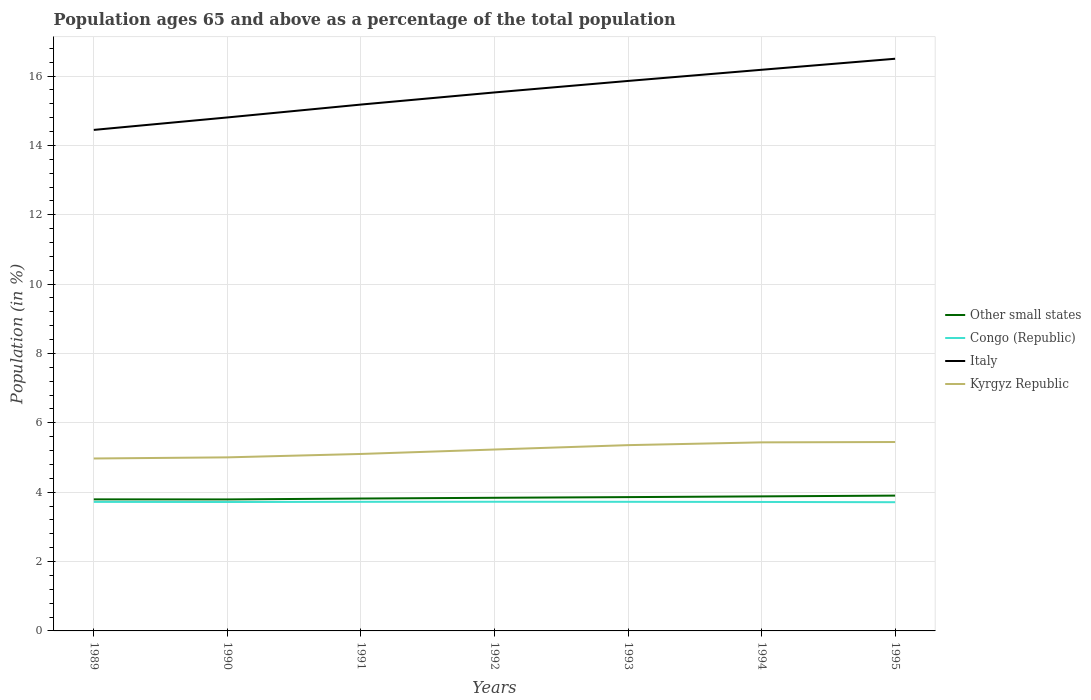How many different coloured lines are there?
Your answer should be very brief. 4. Across all years, what is the maximum percentage of the population ages 65 and above in Italy?
Keep it short and to the point. 14.45. What is the total percentage of the population ages 65 and above in Italy in the graph?
Provide a short and direct response. -1.69. What is the difference between the highest and the second highest percentage of the population ages 65 and above in Other small states?
Your response must be concise. 0.11. Is the percentage of the population ages 65 and above in Other small states strictly greater than the percentage of the population ages 65 and above in Italy over the years?
Offer a very short reply. Yes. What is the difference between two consecutive major ticks on the Y-axis?
Ensure brevity in your answer.  2. Where does the legend appear in the graph?
Your answer should be compact. Center right. How many legend labels are there?
Make the answer very short. 4. How are the legend labels stacked?
Provide a succinct answer. Vertical. What is the title of the graph?
Your answer should be compact. Population ages 65 and above as a percentage of the total population. What is the label or title of the X-axis?
Your answer should be very brief. Years. What is the Population (in %) in Other small states in 1989?
Provide a succinct answer. 3.79. What is the Population (in %) of Congo (Republic) in 1989?
Provide a succinct answer. 3.72. What is the Population (in %) in Italy in 1989?
Offer a terse response. 14.45. What is the Population (in %) in Kyrgyz Republic in 1989?
Keep it short and to the point. 4.97. What is the Population (in %) in Other small states in 1990?
Offer a very short reply. 3.79. What is the Population (in %) of Congo (Republic) in 1990?
Keep it short and to the point. 3.72. What is the Population (in %) of Italy in 1990?
Ensure brevity in your answer.  14.81. What is the Population (in %) in Kyrgyz Republic in 1990?
Give a very brief answer. 5. What is the Population (in %) in Other small states in 1991?
Provide a short and direct response. 3.82. What is the Population (in %) in Congo (Republic) in 1991?
Offer a very short reply. 3.72. What is the Population (in %) of Italy in 1991?
Provide a succinct answer. 15.18. What is the Population (in %) of Kyrgyz Republic in 1991?
Offer a very short reply. 5.1. What is the Population (in %) in Other small states in 1992?
Give a very brief answer. 3.84. What is the Population (in %) in Congo (Republic) in 1992?
Provide a succinct answer. 3.72. What is the Population (in %) in Italy in 1992?
Give a very brief answer. 15.53. What is the Population (in %) in Kyrgyz Republic in 1992?
Your response must be concise. 5.23. What is the Population (in %) in Other small states in 1993?
Ensure brevity in your answer.  3.86. What is the Population (in %) of Congo (Republic) in 1993?
Offer a very short reply. 3.72. What is the Population (in %) in Italy in 1993?
Offer a terse response. 15.86. What is the Population (in %) of Kyrgyz Republic in 1993?
Make the answer very short. 5.36. What is the Population (in %) of Other small states in 1994?
Give a very brief answer. 3.88. What is the Population (in %) of Congo (Republic) in 1994?
Your response must be concise. 3.72. What is the Population (in %) of Italy in 1994?
Your answer should be compact. 16.18. What is the Population (in %) in Kyrgyz Republic in 1994?
Your response must be concise. 5.44. What is the Population (in %) in Other small states in 1995?
Ensure brevity in your answer.  3.9. What is the Population (in %) of Congo (Republic) in 1995?
Your response must be concise. 3.71. What is the Population (in %) in Italy in 1995?
Ensure brevity in your answer.  16.5. What is the Population (in %) of Kyrgyz Republic in 1995?
Make the answer very short. 5.45. Across all years, what is the maximum Population (in %) in Other small states?
Give a very brief answer. 3.9. Across all years, what is the maximum Population (in %) in Congo (Republic)?
Make the answer very short. 3.72. Across all years, what is the maximum Population (in %) of Italy?
Ensure brevity in your answer.  16.5. Across all years, what is the maximum Population (in %) in Kyrgyz Republic?
Your answer should be very brief. 5.45. Across all years, what is the minimum Population (in %) in Other small states?
Your answer should be compact. 3.79. Across all years, what is the minimum Population (in %) in Congo (Republic)?
Provide a succinct answer. 3.71. Across all years, what is the minimum Population (in %) of Italy?
Give a very brief answer. 14.45. Across all years, what is the minimum Population (in %) in Kyrgyz Republic?
Provide a short and direct response. 4.97. What is the total Population (in %) of Other small states in the graph?
Ensure brevity in your answer.  26.88. What is the total Population (in %) in Congo (Republic) in the graph?
Provide a short and direct response. 26.04. What is the total Population (in %) of Italy in the graph?
Keep it short and to the point. 108.5. What is the total Population (in %) of Kyrgyz Republic in the graph?
Ensure brevity in your answer.  36.55. What is the difference between the Population (in %) of Other small states in 1989 and that in 1990?
Give a very brief answer. 0. What is the difference between the Population (in %) in Congo (Republic) in 1989 and that in 1990?
Provide a short and direct response. 0. What is the difference between the Population (in %) of Italy in 1989 and that in 1990?
Ensure brevity in your answer.  -0.36. What is the difference between the Population (in %) in Kyrgyz Republic in 1989 and that in 1990?
Make the answer very short. -0.03. What is the difference between the Population (in %) in Other small states in 1989 and that in 1991?
Offer a very short reply. -0.02. What is the difference between the Population (in %) of Congo (Republic) in 1989 and that in 1991?
Provide a short and direct response. -0. What is the difference between the Population (in %) of Italy in 1989 and that in 1991?
Offer a very short reply. -0.73. What is the difference between the Population (in %) of Kyrgyz Republic in 1989 and that in 1991?
Offer a terse response. -0.13. What is the difference between the Population (in %) in Other small states in 1989 and that in 1992?
Give a very brief answer. -0.05. What is the difference between the Population (in %) in Congo (Republic) in 1989 and that in 1992?
Keep it short and to the point. -0. What is the difference between the Population (in %) in Italy in 1989 and that in 1992?
Provide a succinct answer. -1.08. What is the difference between the Population (in %) of Kyrgyz Republic in 1989 and that in 1992?
Provide a succinct answer. -0.26. What is the difference between the Population (in %) of Other small states in 1989 and that in 1993?
Keep it short and to the point. -0.07. What is the difference between the Population (in %) of Congo (Republic) in 1989 and that in 1993?
Offer a very short reply. -0. What is the difference between the Population (in %) in Italy in 1989 and that in 1993?
Your answer should be very brief. -1.41. What is the difference between the Population (in %) in Kyrgyz Republic in 1989 and that in 1993?
Your answer should be very brief. -0.38. What is the difference between the Population (in %) of Other small states in 1989 and that in 1994?
Your answer should be very brief. -0.09. What is the difference between the Population (in %) in Congo (Republic) in 1989 and that in 1994?
Provide a succinct answer. 0. What is the difference between the Population (in %) of Italy in 1989 and that in 1994?
Offer a very short reply. -1.73. What is the difference between the Population (in %) in Kyrgyz Republic in 1989 and that in 1994?
Give a very brief answer. -0.46. What is the difference between the Population (in %) in Other small states in 1989 and that in 1995?
Your answer should be very brief. -0.11. What is the difference between the Population (in %) in Congo (Republic) in 1989 and that in 1995?
Give a very brief answer. 0.01. What is the difference between the Population (in %) of Italy in 1989 and that in 1995?
Provide a short and direct response. -2.05. What is the difference between the Population (in %) of Kyrgyz Republic in 1989 and that in 1995?
Offer a very short reply. -0.47. What is the difference between the Population (in %) of Other small states in 1990 and that in 1991?
Your answer should be compact. -0.03. What is the difference between the Population (in %) of Congo (Republic) in 1990 and that in 1991?
Provide a short and direct response. -0.01. What is the difference between the Population (in %) in Italy in 1990 and that in 1991?
Your answer should be compact. -0.37. What is the difference between the Population (in %) of Kyrgyz Republic in 1990 and that in 1991?
Provide a short and direct response. -0.1. What is the difference between the Population (in %) of Other small states in 1990 and that in 1992?
Keep it short and to the point. -0.05. What is the difference between the Population (in %) of Congo (Republic) in 1990 and that in 1992?
Give a very brief answer. -0.01. What is the difference between the Population (in %) in Italy in 1990 and that in 1992?
Provide a short and direct response. -0.72. What is the difference between the Population (in %) in Kyrgyz Republic in 1990 and that in 1992?
Provide a succinct answer. -0.23. What is the difference between the Population (in %) in Other small states in 1990 and that in 1993?
Ensure brevity in your answer.  -0.07. What is the difference between the Population (in %) in Congo (Republic) in 1990 and that in 1993?
Keep it short and to the point. -0.01. What is the difference between the Population (in %) in Italy in 1990 and that in 1993?
Provide a succinct answer. -1.05. What is the difference between the Population (in %) in Kyrgyz Republic in 1990 and that in 1993?
Your answer should be compact. -0.35. What is the difference between the Population (in %) of Other small states in 1990 and that in 1994?
Provide a succinct answer. -0.09. What is the difference between the Population (in %) in Congo (Republic) in 1990 and that in 1994?
Your response must be concise. -0. What is the difference between the Population (in %) in Italy in 1990 and that in 1994?
Give a very brief answer. -1.37. What is the difference between the Population (in %) in Kyrgyz Republic in 1990 and that in 1994?
Your response must be concise. -0.43. What is the difference between the Population (in %) in Other small states in 1990 and that in 1995?
Keep it short and to the point. -0.11. What is the difference between the Population (in %) of Congo (Republic) in 1990 and that in 1995?
Provide a succinct answer. 0.01. What is the difference between the Population (in %) of Italy in 1990 and that in 1995?
Offer a very short reply. -1.69. What is the difference between the Population (in %) of Kyrgyz Republic in 1990 and that in 1995?
Give a very brief answer. -0.44. What is the difference between the Population (in %) in Other small states in 1991 and that in 1992?
Provide a succinct answer. -0.02. What is the difference between the Population (in %) in Congo (Republic) in 1991 and that in 1992?
Offer a very short reply. -0. What is the difference between the Population (in %) of Italy in 1991 and that in 1992?
Make the answer very short. -0.35. What is the difference between the Population (in %) of Kyrgyz Republic in 1991 and that in 1992?
Your response must be concise. -0.13. What is the difference between the Population (in %) of Other small states in 1991 and that in 1993?
Keep it short and to the point. -0.04. What is the difference between the Population (in %) of Congo (Republic) in 1991 and that in 1993?
Provide a succinct answer. -0. What is the difference between the Population (in %) of Italy in 1991 and that in 1993?
Your answer should be very brief. -0.68. What is the difference between the Population (in %) in Kyrgyz Republic in 1991 and that in 1993?
Your answer should be compact. -0.25. What is the difference between the Population (in %) in Other small states in 1991 and that in 1994?
Offer a terse response. -0.06. What is the difference between the Population (in %) of Congo (Republic) in 1991 and that in 1994?
Your answer should be compact. 0. What is the difference between the Population (in %) in Italy in 1991 and that in 1994?
Offer a very short reply. -1. What is the difference between the Population (in %) in Kyrgyz Republic in 1991 and that in 1994?
Keep it short and to the point. -0.33. What is the difference between the Population (in %) in Other small states in 1991 and that in 1995?
Your response must be concise. -0.08. What is the difference between the Population (in %) of Congo (Republic) in 1991 and that in 1995?
Offer a very short reply. 0.01. What is the difference between the Population (in %) of Italy in 1991 and that in 1995?
Offer a terse response. -1.32. What is the difference between the Population (in %) in Kyrgyz Republic in 1991 and that in 1995?
Keep it short and to the point. -0.34. What is the difference between the Population (in %) of Other small states in 1992 and that in 1993?
Provide a succinct answer. -0.02. What is the difference between the Population (in %) in Congo (Republic) in 1992 and that in 1993?
Offer a terse response. 0. What is the difference between the Population (in %) in Italy in 1992 and that in 1993?
Your answer should be very brief. -0.33. What is the difference between the Population (in %) of Kyrgyz Republic in 1992 and that in 1993?
Offer a very short reply. -0.13. What is the difference between the Population (in %) in Other small states in 1992 and that in 1994?
Offer a terse response. -0.04. What is the difference between the Population (in %) in Congo (Republic) in 1992 and that in 1994?
Your answer should be compact. 0.01. What is the difference between the Population (in %) of Italy in 1992 and that in 1994?
Ensure brevity in your answer.  -0.65. What is the difference between the Population (in %) of Kyrgyz Republic in 1992 and that in 1994?
Ensure brevity in your answer.  -0.21. What is the difference between the Population (in %) in Other small states in 1992 and that in 1995?
Your answer should be compact. -0.06. What is the difference between the Population (in %) in Congo (Republic) in 1992 and that in 1995?
Ensure brevity in your answer.  0.01. What is the difference between the Population (in %) of Italy in 1992 and that in 1995?
Keep it short and to the point. -0.97. What is the difference between the Population (in %) in Kyrgyz Republic in 1992 and that in 1995?
Provide a succinct answer. -0.22. What is the difference between the Population (in %) in Other small states in 1993 and that in 1994?
Ensure brevity in your answer.  -0.02. What is the difference between the Population (in %) in Congo (Republic) in 1993 and that in 1994?
Make the answer very short. 0. What is the difference between the Population (in %) in Italy in 1993 and that in 1994?
Your response must be concise. -0.32. What is the difference between the Population (in %) in Kyrgyz Republic in 1993 and that in 1994?
Your answer should be compact. -0.08. What is the difference between the Population (in %) in Other small states in 1993 and that in 1995?
Provide a short and direct response. -0.04. What is the difference between the Population (in %) in Congo (Republic) in 1993 and that in 1995?
Your response must be concise. 0.01. What is the difference between the Population (in %) of Italy in 1993 and that in 1995?
Keep it short and to the point. -0.64. What is the difference between the Population (in %) of Kyrgyz Republic in 1993 and that in 1995?
Keep it short and to the point. -0.09. What is the difference between the Population (in %) of Other small states in 1994 and that in 1995?
Your answer should be compact. -0.02. What is the difference between the Population (in %) in Congo (Republic) in 1994 and that in 1995?
Provide a short and direct response. 0.01. What is the difference between the Population (in %) of Italy in 1994 and that in 1995?
Offer a very short reply. -0.32. What is the difference between the Population (in %) in Kyrgyz Republic in 1994 and that in 1995?
Offer a very short reply. -0.01. What is the difference between the Population (in %) in Other small states in 1989 and the Population (in %) in Congo (Republic) in 1990?
Make the answer very short. 0.08. What is the difference between the Population (in %) of Other small states in 1989 and the Population (in %) of Italy in 1990?
Provide a short and direct response. -11.01. What is the difference between the Population (in %) in Other small states in 1989 and the Population (in %) in Kyrgyz Republic in 1990?
Offer a terse response. -1.21. What is the difference between the Population (in %) of Congo (Republic) in 1989 and the Population (in %) of Italy in 1990?
Your answer should be compact. -11.09. What is the difference between the Population (in %) of Congo (Republic) in 1989 and the Population (in %) of Kyrgyz Republic in 1990?
Offer a terse response. -1.28. What is the difference between the Population (in %) of Italy in 1989 and the Population (in %) of Kyrgyz Republic in 1990?
Offer a terse response. 9.44. What is the difference between the Population (in %) in Other small states in 1989 and the Population (in %) in Congo (Republic) in 1991?
Offer a terse response. 0.07. What is the difference between the Population (in %) in Other small states in 1989 and the Population (in %) in Italy in 1991?
Make the answer very short. -11.38. What is the difference between the Population (in %) of Other small states in 1989 and the Population (in %) of Kyrgyz Republic in 1991?
Provide a short and direct response. -1.31. What is the difference between the Population (in %) of Congo (Republic) in 1989 and the Population (in %) of Italy in 1991?
Your answer should be compact. -11.46. What is the difference between the Population (in %) in Congo (Republic) in 1989 and the Population (in %) in Kyrgyz Republic in 1991?
Provide a succinct answer. -1.38. What is the difference between the Population (in %) in Italy in 1989 and the Population (in %) in Kyrgyz Republic in 1991?
Provide a succinct answer. 9.34. What is the difference between the Population (in %) of Other small states in 1989 and the Population (in %) of Congo (Republic) in 1992?
Give a very brief answer. 0.07. What is the difference between the Population (in %) in Other small states in 1989 and the Population (in %) in Italy in 1992?
Your response must be concise. -11.73. What is the difference between the Population (in %) in Other small states in 1989 and the Population (in %) in Kyrgyz Republic in 1992?
Ensure brevity in your answer.  -1.44. What is the difference between the Population (in %) in Congo (Republic) in 1989 and the Population (in %) in Italy in 1992?
Ensure brevity in your answer.  -11.81. What is the difference between the Population (in %) of Congo (Republic) in 1989 and the Population (in %) of Kyrgyz Republic in 1992?
Give a very brief answer. -1.51. What is the difference between the Population (in %) in Italy in 1989 and the Population (in %) in Kyrgyz Republic in 1992?
Make the answer very short. 9.22. What is the difference between the Population (in %) in Other small states in 1989 and the Population (in %) in Congo (Republic) in 1993?
Provide a short and direct response. 0.07. What is the difference between the Population (in %) of Other small states in 1989 and the Population (in %) of Italy in 1993?
Give a very brief answer. -12.07. What is the difference between the Population (in %) in Other small states in 1989 and the Population (in %) in Kyrgyz Republic in 1993?
Make the answer very short. -1.56. What is the difference between the Population (in %) of Congo (Republic) in 1989 and the Population (in %) of Italy in 1993?
Provide a succinct answer. -12.14. What is the difference between the Population (in %) in Congo (Republic) in 1989 and the Population (in %) in Kyrgyz Republic in 1993?
Provide a succinct answer. -1.64. What is the difference between the Population (in %) in Italy in 1989 and the Population (in %) in Kyrgyz Republic in 1993?
Provide a succinct answer. 9.09. What is the difference between the Population (in %) in Other small states in 1989 and the Population (in %) in Congo (Republic) in 1994?
Ensure brevity in your answer.  0.07. What is the difference between the Population (in %) in Other small states in 1989 and the Population (in %) in Italy in 1994?
Give a very brief answer. -12.39. What is the difference between the Population (in %) of Other small states in 1989 and the Population (in %) of Kyrgyz Republic in 1994?
Your response must be concise. -1.64. What is the difference between the Population (in %) of Congo (Republic) in 1989 and the Population (in %) of Italy in 1994?
Your answer should be very brief. -12.46. What is the difference between the Population (in %) of Congo (Republic) in 1989 and the Population (in %) of Kyrgyz Republic in 1994?
Provide a short and direct response. -1.72. What is the difference between the Population (in %) in Italy in 1989 and the Population (in %) in Kyrgyz Republic in 1994?
Offer a very short reply. 9.01. What is the difference between the Population (in %) in Other small states in 1989 and the Population (in %) in Congo (Republic) in 1995?
Provide a short and direct response. 0.08. What is the difference between the Population (in %) in Other small states in 1989 and the Population (in %) in Italy in 1995?
Your response must be concise. -12.71. What is the difference between the Population (in %) of Other small states in 1989 and the Population (in %) of Kyrgyz Republic in 1995?
Provide a succinct answer. -1.65. What is the difference between the Population (in %) in Congo (Republic) in 1989 and the Population (in %) in Italy in 1995?
Offer a very short reply. -12.78. What is the difference between the Population (in %) of Congo (Republic) in 1989 and the Population (in %) of Kyrgyz Republic in 1995?
Your answer should be compact. -1.73. What is the difference between the Population (in %) in Italy in 1989 and the Population (in %) in Kyrgyz Republic in 1995?
Ensure brevity in your answer.  9. What is the difference between the Population (in %) in Other small states in 1990 and the Population (in %) in Congo (Republic) in 1991?
Give a very brief answer. 0.07. What is the difference between the Population (in %) of Other small states in 1990 and the Population (in %) of Italy in 1991?
Ensure brevity in your answer.  -11.39. What is the difference between the Population (in %) of Other small states in 1990 and the Population (in %) of Kyrgyz Republic in 1991?
Your answer should be compact. -1.31. What is the difference between the Population (in %) of Congo (Republic) in 1990 and the Population (in %) of Italy in 1991?
Your answer should be very brief. -11.46. What is the difference between the Population (in %) of Congo (Republic) in 1990 and the Population (in %) of Kyrgyz Republic in 1991?
Your answer should be very brief. -1.39. What is the difference between the Population (in %) of Italy in 1990 and the Population (in %) of Kyrgyz Republic in 1991?
Offer a terse response. 9.7. What is the difference between the Population (in %) of Other small states in 1990 and the Population (in %) of Congo (Republic) in 1992?
Your answer should be compact. 0.07. What is the difference between the Population (in %) in Other small states in 1990 and the Population (in %) in Italy in 1992?
Offer a very short reply. -11.74. What is the difference between the Population (in %) in Other small states in 1990 and the Population (in %) in Kyrgyz Republic in 1992?
Provide a short and direct response. -1.44. What is the difference between the Population (in %) in Congo (Republic) in 1990 and the Population (in %) in Italy in 1992?
Make the answer very short. -11.81. What is the difference between the Population (in %) of Congo (Republic) in 1990 and the Population (in %) of Kyrgyz Republic in 1992?
Give a very brief answer. -1.51. What is the difference between the Population (in %) of Italy in 1990 and the Population (in %) of Kyrgyz Republic in 1992?
Offer a terse response. 9.58. What is the difference between the Population (in %) of Other small states in 1990 and the Population (in %) of Congo (Republic) in 1993?
Offer a terse response. 0.07. What is the difference between the Population (in %) of Other small states in 1990 and the Population (in %) of Italy in 1993?
Your response must be concise. -12.07. What is the difference between the Population (in %) of Other small states in 1990 and the Population (in %) of Kyrgyz Republic in 1993?
Your answer should be very brief. -1.57. What is the difference between the Population (in %) in Congo (Republic) in 1990 and the Population (in %) in Italy in 1993?
Make the answer very short. -12.14. What is the difference between the Population (in %) in Congo (Republic) in 1990 and the Population (in %) in Kyrgyz Republic in 1993?
Provide a short and direct response. -1.64. What is the difference between the Population (in %) of Italy in 1990 and the Population (in %) of Kyrgyz Republic in 1993?
Give a very brief answer. 9.45. What is the difference between the Population (in %) in Other small states in 1990 and the Population (in %) in Congo (Republic) in 1994?
Your answer should be very brief. 0.07. What is the difference between the Population (in %) in Other small states in 1990 and the Population (in %) in Italy in 1994?
Ensure brevity in your answer.  -12.39. What is the difference between the Population (in %) of Other small states in 1990 and the Population (in %) of Kyrgyz Republic in 1994?
Offer a terse response. -1.65. What is the difference between the Population (in %) of Congo (Republic) in 1990 and the Population (in %) of Italy in 1994?
Give a very brief answer. -12.46. What is the difference between the Population (in %) of Congo (Republic) in 1990 and the Population (in %) of Kyrgyz Republic in 1994?
Your answer should be very brief. -1.72. What is the difference between the Population (in %) in Italy in 1990 and the Population (in %) in Kyrgyz Republic in 1994?
Give a very brief answer. 9.37. What is the difference between the Population (in %) in Other small states in 1990 and the Population (in %) in Congo (Republic) in 1995?
Provide a succinct answer. 0.08. What is the difference between the Population (in %) of Other small states in 1990 and the Population (in %) of Italy in 1995?
Your answer should be compact. -12.71. What is the difference between the Population (in %) in Other small states in 1990 and the Population (in %) in Kyrgyz Republic in 1995?
Offer a terse response. -1.66. What is the difference between the Population (in %) of Congo (Republic) in 1990 and the Population (in %) of Italy in 1995?
Offer a terse response. -12.78. What is the difference between the Population (in %) in Congo (Republic) in 1990 and the Population (in %) in Kyrgyz Republic in 1995?
Provide a succinct answer. -1.73. What is the difference between the Population (in %) of Italy in 1990 and the Population (in %) of Kyrgyz Republic in 1995?
Provide a short and direct response. 9.36. What is the difference between the Population (in %) of Other small states in 1991 and the Population (in %) of Congo (Republic) in 1992?
Provide a succinct answer. 0.09. What is the difference between the Population (in %) in Other small states in 1991 and the Population (in %) in Italy in 1992?
Provide a succinct answer. -11.71. What is the difference between the Population (in %) of Other small states in 1991 and the Population (in %) of Kyrgyz Republic in 1992?
Your answer should be compact. -1.41. What is the difference between the Population (in %) in Congo (Republic) in 1991 and the Population (in %) in Italy in 1992?
Make the answer very short. -11.8. What is the difference between the Population (in %) in Congo (Republic) in 1991 and the Population (in %) in Kyrgyz Republic in 1992?
Your answer should be compact. -1.51. What is the difference between the Population (in %) in Italy in 1991 and the Population (in %) in Kyrgyz Republic in 1992?
Ensure brevity in your answer.  9.95. What is the difference between the Population (in %) in Other small states in 1991 and the Population (in %) in Congo (Republic) in 1993?
Offer a very short reply. 0.09. What is the difference between the Population (in %) of Other small states in 1991 and the Population (in %) of Italy in 1993?
Your response must be concise. -12.04. What is the difference between the Population (in %) of Other small states in 1991 and the Population (in %) of Kyrgyz Republic in 1993?
Your answer should be very brief. -1.54. What is the difference between the Population (in %) of Congo (Republic) in 1991 and the Population (in %) of Italy in 1993?
Ensure brevity in your answer.  -12.14. What is the difference between the Population (in %) in Congo (Republic) in 1991 and the Population (in %) in Kyrgyz Republic in 1993?
Give a very brief answer. -1.63. What is the difference between the Population (in %) of Italy in 1991 and the Population (in %) of Kyrgyz Republic in 1993?
Provide a succinct answer. 9.82. What is the difference between the Population (in %) in Other small states in 1991 and the Population (in %) in Congo (Republic) in 1994?
Your answer should be compact. 0.1. What is the difference between the Population (in %) of Other small states in 1991 and the Population (in %) of Italy in 1994?
Provide a short and direct response. -12.36. What is the difference between the Population (in %) in Other small states in 1991 and the Population (in %) in Kyrgyz Republic in 1994?
Give a very brief answer. -1.62. What is the difference between the Population (in %) of Congo (Republic) in 1991 and the Population (in %) of Italy in 1994?
Offer a terse response. -12.46. What is the difference between the Population (in %) of Congo (Republic) in 1991 and the Population (in %) of Kyrgyz Republic in 1994?
Give a very brief answer. -1.71. What is the difference between the Population (in %) of Italy in 1991 and the Population (in %) of Kyrgyz Republic in 1994?
Your answer should be very brief. 9.74. What is the difference between the Population (in %) of Other small states in 1991 and the Population (in %) of Congo (Republic) in 1995?
Make the answer very short. 0.11. What is the difference between the Population (in %) of Other small states in 1991 and the Population (in %) of Italy in 1995?
Make the answer very short. -12.68. What is the difference between the Population (in %) in Other small states in 1991 and the Population (in %) in Kyrgyz Republic in 1995?
Keep it short and to the point. -1.63. What is the difference between the Population (in %) in Congo (Republic) in 1991 and the Population (in %) in Italy in 1995?
Provide a short and direct response. -12.78. What is the difference between the Population (in %) in Congo (Republic) in 1991 and the Population (in %) in Kyrgyz Republic in 1995?
Give a very brief answer. -1.72. What is the difference between the Population (in %) in Italy in 1991 and the Population (in %) in Kyrgyz Republic in 1995?
Give a very brief answer. 9.73. What is the difference between the Population (in %) of Other small states in 1992 and the Population (in %) of Congo (Republic) in 1993?
Keep it short and to the point. 0.12. What is the difference between the Population (in %) of Other small states in 1992 and the Population (in %) of Italy in 1993?
Your answer should be compact. -12.02. What is the difference between the Population (in %) of Other small states in 1992 and the Population (in %) of Kyrgyz Republic in 1993?
Keep it short and to the point. -1.52. What is the difference between the Population (in %) of Congo (Republic) in 1992 and the Population (in %) of Italy in 1993?
Keep it short and to the point. -12.13. What is the difference between the Population (in %) in Congo (Republic) in 1992 and the Population (in %) in Kyrgyz Republic in 1993?
Offer a very short reply. -1.63. What is the difference between the Population (in %) in Italy in 1992 and the Population (in %) in Kyrgyz Republic in 1993?
Keep it short and to the point. 10.17. What is the difference between the Population (in %) in Other small states in 1992 and the Population (in %) in Congo (Republic) in 1994?
Your answer should be compact. 0.12. What is the difference between the Population (in %) of Other small states in 1992 and the Population (in %) of Italy in 1994?
Give a very brief answer. -12.34. What is the difference between the Population (in %) in Other small states in 1992 and the Population (in %) in Kyrgyz Republic in 1994?
Give a very brief answer. -1.6. What is the difference between the Population (in %) in Congo (Republic) in 1992 and the Population (in %) in Italy in 1994?
Ensure brevity in your answer.  -12.46. What is the difference between the Population (in %) of Congo (Republic) in 1992 and the Population (in %) of Kyrgyz Republic in 1994?
Your answer should be compact. -1.71. What is the difference between the Population (in %) of Italy in 1992 and the Population (in %) of Kyrgyz Republic in 1994?
Give a very brief answer. 10.09. What is the difference between the Population (in %) of Other small states in 1992 and the Population (in %) of Congo (Republic) in 1995?
Ensure brevity in your answer.  0.13. What is the difference between the Population (in %) of Other small states in 1992 and the Population (in %) of Italy in 1995?
Give a very brief answer. -12.66. What is the difference between the Population (in %) of Other small states in 1992 and the Population (in %) of Kyrgyz Republic in 1995?
Provide a short and direct response. -1.61. What is the difference between the Population (in %) of Congo (Republic) in 1992 and the Population (in %) of Italy in 1995?
Your response must be concise. -12.77. What is the difference between the Population (in %) of Congo (Republic) in 1992 and the Population (in %) of Kyrgyz Republic in 1995?
Offer a terse response. -1.72. What is the difference between the Population (in %) of Italy in 1992 and the Population (in %) of Kyrgyz Republic in 1995?
Provide a short and direct response. 10.08. What is the difference between the Population (in %) of Other small states in 1993 and the Population (in %) of Congo (Republic) in 1994?
Ensure brevity in your answer.  0.14. What is the difference between the Population (in %) in Other small states in 1993 and the Population (in %) in Italy in 1994?
Your answer should be compact. -12.32. What is the difference between the Population (in %) in Other small states in 1993 and the Population (in %) in Kyrgyz Republic in 1994?
Your answer should be very brief. -1.58. What is the difference between the Population (in %) of Congo (Republic) in 1993 and the Population (in %) of Italy in 1994?
Give a very brief answer. -12.46. What is the difference between the Population (in %) in Congo (Republic) in 1993 and the Population (in %) in Kyrgyz Republic in 1994?
Make the answer very short. -1.71. What is the difference between the Population (in %) of Italy in 1993 and the Population (in %) of Kyrgyz Republic in 1994?
Your answer should be very brief. 10.42. What is the difference between the Population (in %) in Other small states in 1993 and the Population (in %) in Congo (Republic) in 1995?
Give a very brief answer. 0.15. What is the difference between the Population (in %) in Other small states in 1993 and the Population (in %) in Italy in 1995?
Your answer should be compact. -12.64. What is the difference between the Population (in %) of Other small states in 1993 and the Population (in %) of Kyrgyz Republic in 1995?
Provide a short and direct response. -1.59. What is the difference between the Population (in %) in Congo (Republic) in 1993 and the Population (in %) in Italy in 1995?
Ensure brevity in your answer.  -12.78. What is the difference between the Population (in %) of Congo (Republic) in 1993 and the Population (in %) of Kyrgyz Republic in 1995?
Provide a succinct answer. -1.72. What is the difference between the Population (in %) of Italy in 1993 and the Population (in %) of Kyrgyz Republic in 1995?
Ensure brevity in your answer.  10.41. What is the difference between the Population (in %) of Other small states in 1994 and the Population (in %) of Congo (Republic) in 1995?
Your answer should be compact. 0.17. What is the difference between the Population (in %) in Other small states in 1994 and the Population (in %) in Italy in 1995?
Keep it short and to the point. -12.62. What is the difference between the Population (in %) of Other small states in 1994 and the Population (in %) of Kyrgyz Republic in 1995?
Keep it short and to the point. -1.57. What is the difference between the Population (in %) in Congo (Republic) in 1994 and the Population (in %) in Italy in 1995?
Keep it short and to the point. -12.78. What is the difference between the Population (in %) of Congo (Republic) in 1994 and the Population (in %) of Kyrgyz Republic in 1995?
Your answer should be compact. -1.73. What is the difference between the Population (in %) in Italy in 1994 and the Population (in %) in Kyrgyz Republic in 1995?
Provide a short and direct response. 10.73. What is the average Population (in %) of Other small states per year?
Provide a short and direct response. 3.84. What is the average Population (in %) of Congo (Republic) per year?
Your response must be concise. 3.72. What is the average Population (in %) of Italy per year?
Keep it short and to the point. 15.5. What is the average Population (in %) in Kyrgyz Republic per year?
Give a very brief answer. 5.22. In the year 1989, what is the difference between the Population (in %) of Other small states and Population (in %) of Congo (Republic)?
Provide a succinct answer. 0.07. In the year 1989, what is the difference between the Population (in %) of Other small states and Population (in %) of Italy?
Your response must be concise. -10.65. In the year 1989, what is the difference between the Population (in %) in Other small states and Population (in %) in Kyrgyz Republic?
Offer a very short reply. -1.18. In the year 1989, what is the difference between the Population (in %) in Congo (Republic) and Population (in %) in Italy?
Your response must be concise. -10.73. In the year 1989, what is the difference between the Population (in %) of Congo (Republic) and Population (in %) of Kyrgyz Republic?
Offer a terse response. -1.25. In the year 1989, what is the difference between the Population (in %) of Italy and Population (in %) of Kyrgyz Republic?
Offer a very short reply. 9.47. In the year 1990, what is the difference between the Population (in %) of Other small states and Population (in %) of Congo (Republic)?
Your answer should be very brief. 0.07. In the year 1990, what is the difference between the Population (in %) of Other small states and Population (in %) of Italy?
Provide a succinct answer. -11.01. In the year 1990, what is the difference between the Population (in %) of Other small states and Population (in %) of Kyrgyz Republic?
Keep it short and to the point. -1.21. In the year 1990, what is the difference between the Population (in %) of Congo (Republic) and Population (in %) of Italy?
Keep it short and to the point. -11.09. In the year 1990, what is the difference between the Population (in %) of Congo (Republic) and Population (in %) of Kyrgyz Republic?
Provide a short and direct response. -1.29. In the year 1990, what is the difference between the Population (in %) of Italy and Population (in %) of Kyrgyz Republic?
Your response must be concise. 9.8. In the year 1991, what is the difference between the Population (in %) of Other small states and Population (in %) of Congo (Republic)?
Provide a succinct answer. 0.1. In the year 1991, what is the difference between the Population (in %) in Other small states and Population (in %) in Italy?
Make the answer very short. -11.36. In the year 1991, what is the difference between the Population (in %) of Other small states and Population (in %) of Kyrgyz Republic?
Keep it short and to the point. -1.29. In the year 1991, what is the difference between the Population (in %) in Congo (Republic) and Population (in %) in Italy?
Your answer should be very brief. -11.46. In the year 1991, what is the difference between the Population (in %) in Congo (Republic) and Population (in %) in Kyrgyz Republic?
Ensure brevity in your answer.  -1.38. In the year 1991, what is the difference between the Population (in %) in Italy and Population (in %) in Kyrgyz Republic?
Keep it short and to the point. 10.07. In the year 1992, what is the difference between the Population (in %) of Other small states and Population (in %) of Congo (Republic)?
Provide a short and direct response. 0.11. In the year 1992, what is the difference between the Population (in %) in Other small states and Population (in %) in Italy?
Offer a terse response. -11.69. In the year 1992, what is the difference between the Population (in %) in Other small states and Population (in %) in Kyrgyz Republic?
Your answer should be compact. -1.39. In the year 1992, what is the difference between the Population (in %) of Congo (Republic) and Population (in %) of Italy?
Offer a very short reply. -11.8. In the year 1992, what is the difference between the Population (in %) of Congo (Republic) and Population (in %) of Kyrgyz Republic?
Offer a very short reply. -1.51. In the year 1992, what is the difference between the Population (in %) in Italy and Population (in %) in Kyrgyz Republic?
Provide a short and direct response. 10.3. In the year 1993, what is the difference between the Population (in %) in Other small states and Population (in %) in Congo (Republic)?
Offer a terse response. 0.14. In the year 1993, what is the difference between the Population (in %) in Other small states and Population (in %) in Italy?
Provide a succinct answer. -12. In the year 1993, what is the difference between the Population (in %) in Other small states and Population (in %) in Kyrgyz Republic?
Offer a very short reply. -1.5. In the year 1993, what is the difference between the Population (in %) of Congo (Republic) and Population (in %) of Italy?
Your response must be concise. -12.14. In the year 1993, what is the difference between the Population (in %) in Congo (Republic) and Population (in %) in Kyrgyz Republic?
Provide a succinct answer. -1.63. In the year 1993, what is the difference between the Population (in %) in Italy and Population (in %) in Kyrgyz Republic?
Make the answer very short. 10.5. In the year 1994, what is the difference between the Population (in %) of Other small states and Population (in %) of Congo (Republic)?
Provide a succinct answer. 0.16. In the year 1994, what is the difference between the Population (in %) in Other small states and Population (in %) in Italy?
Keep it short and to the point. -12.3. In the year 1994, what is the difference between the Population (in %) of Other small states and Population (in %) of Kyrgyz Republic?
Your answer should be compact. -1.56. In the year 1994, what is the difference between the Population (in %) in Congo (Republic) and Population (in %) in Italy?
Offer a very short reply. -12.46. In the year 1994, what is the difference between the Population (in %) of Congo (Republic) and Population (in %) of Kyrgyz Republic?
Provide a succinct answer. -1.72. In the year 1994, what is the difference between the Population (in %) of Italy and Population (in %) of Kyrgyz Republic?
Your answer should be compact. 10.74. In the year 1995, what is the difference between the Population (in %) of Other small states and Population (in %) of Congo (Republic)?
Give a very brief answer. 0.19. In the year 1995, what is the difference between the Population (in %) in Other small states and Population (in %) in Italy?
Your response must be concise. -12.6. In the year 1995, what is the difference between the Population (in %) of Other small states and Population (in %) of Kyrgyz Republic?
Provide a succinct answer. -1.55. In the year 1995, what is the difference between the Population (in %) of Congo (Republic) and Population (in %) of Italy?
Ensure brevity in your answer.  -12.79. In the year 1995, what is the difference between the Population (in %) of Congo (Republic) and Population (in %) of Kyrgyz Republic?
Ensure brevity in your answer.  -1.74. In the year 1995, what is the difference between the Population (in %) in Italy and Population (in %) in Kyrgyz Republic?
Offer a very short reply. 11.05. What is the ratio of the Population (in %) of Other small states in 1989 to that in 1990?
Offer a terse response. 1. What is the ratio of the Population (in %) in Italy in 1989 to that in 1990?
Your answer should be very brief. 0.98. What is the ratio of the Population (in %) of Kyrgyz Republic in 1989 to that in 1990?
Keep it short and to the point. 0.99. What is the ratio of the Population (in %) in Other small states in 1989 to that in 1991?
Your response must be concise. 0.99. What is the ratio of the Population (in %) in Italy in 1989 to that in 1991?
Make the answer very short. 0.95. What is the ratio of the Population (in %) of Kyrgyz Republic in 1989 to that in 1991?
Offer a terse response. 0.97. What is the ratio of the Population (in %) of Italy in 1989 to that in 1992?
Your answer should be very brief. 0.93. What is the ratio of the Population (in %) of Kyrgyz Republic in 1989 to that in 1992?
Offer a very short reply. 0.95. What is the ratio of the Population (in %) in Other small states in 1989 to that in 1993?
Your answer should be very brief. 0.98. What is the ratio of the Population (in %) in Congo (Republic) in 1989 to that in 1993?
Ensure brevity in your answer.  1. What is the ratio of the Population (in %) in Italy in 1989 to that in 1993?
Ensure brevity in your answer.  0.91. What is the ratio of the Population (in %) of Kyrgyz Republic in 1989 to that in 1993?
Make the answer very short. 0.93. What is the ratio of the Population (in %) in Other small states in 1989 to that in 1994?
Provide a short and direct response. 0.98. What is the ratio of the Population (in %) in Congo (Republic) in 1989 to that in 1994?
Your response must be concise. 1. What is the ratio of the Population (in %) of Italy in 1989 to that in 1994?
Ensure brevity in your answer.  0.89. What is the ratio of the Population (in %) of Kyrgyz Republic in 1989 to that in 1994?
Make the answer very short. 0.91. What is the ratio of the Population (in %) in Other small states in 1989 to that in 1995?
Ensure brevity in your answer.  0.97. What is the ratio of the Population (in %) in Italy in 1989 to that in 1995?
Your answer should be very brief. 0.88. What is the ratio of the Population (in %) of Kyrgyz Republic in 1989 to that in 1995?
Provide a short and direct response. 0.91. What is the ratio of the Population (in %) in Congo (Republic) in 1990 to that in 1991?
Keep it short and to the point. 1. What is the ratio of the Population (in %) of Italy in 1990 to that in 1991?
Give a very brief answer. 0.98. What is the ratio of the Population (in %) of Kyrgyz Republic in 1990 to that in 1991?
Ensure brevity in your answer.  0.98. What is the ratio of the Population (in %) of Other small states in 1990 to that in 1992?
Your answer should be compact. 0.99. What is the ratio of the Population (in %) of Italy in 1990 to that in 1992?
Give a very brief answer. 0.95. What is the ratio of the Population (in %) in Kyrgyz Republic in 1990 to that in 1992?
Your answer should be compact. 0.96. What is the ratio of the Population (in %) of Other small states in 1990 to that in 1993?
Provide a succinct answer. 0.98. What is the ratio of the Population (in %) in Italy in 1990 to that in 1993?
Offer a very short reply. 0.93. What is the ratio of the Population (in %) in Kyrgyz Republic in 1990 to that in 1993?
Provide a succinct answer. 0.93. What is the ratio of the Population (in %) in Other small states in 1990 to that in 1994?
Make the answer very short. 0.98. What is the ratio of the Population (in %) of Italy in 1990 to that in 1994?
Provide a short and direct response. 0.92. What is the ratio of the Population (in %) of Kyrgyz Republic in 1990 to that in 1994?
Make the answer very short. 0.92. What is the ratio of the Population (in %) of Other small states in 1990 to that in 1995?
Your answer should be very brief. 0.97. What is the ratio of the Population (in %) of Italy in 1990 to that in 1995?
Keep it short and to the point. 0.9. What is the ratio of the Population (in %) of Kyrgyz Republic in 1990 to that in 1995?
Your answer should be very brief. 0.92. What is the ratio of the Population (in %) of Other small states in 1991 to that in 1992?
Keep it short and to the point. 0.99. What is the ratio of the Population (in %) of Congo (Republic) in 1991 to that in 1992?
Provide a succinct answer. 1. What is the ratio of the Population (in %) in Italy in 1991 to that in 1992?
Your response must be concise. 0.98. What is the ratio of the Population (in %) of Kyrgyz Republic in 1991 to that in 1992?
Provide a succinct answer. 0.98. What is the ratio of the Population (in %) of Other small states in 1991 to that in 1993?
Make the answer very short. 0.99. What is the ratio of the Population (in %) in Congo (Republic) in 1991 to that in 1993?
Your answer should be very brief. 1. What is the ratio of the Population (in %) in Italy in 1991 to that in 1993?
Make the answer very short. 0.96. What is the ratio of the Population (in %) in Kyrgyz Republic in 1991 to that in 1993?
Make the answer very short. 0.95. What is the ratio of the Population (in %) of Other small states in 1991 to that in 1994?
Give a very brief answer. 0.98. What is the ratio of the Population (in %) in Congo (Republic) in 1991 to that in 1994?
Keep it short and to the point. 1. What is the ratio of the Population (in %) of Italy in 1991 to that in 1994?
Keep it short and to the point. 0.94. What is the ratio of the Population (in %) in Kyrgyz Republic in 1991 to that in 1994?
Offer a very short reply. 0.94. What is the ratio of the Population (in %) of Other small states in 1991 to that in 1995?
Make the answer very short. 0.98. What is the ratio of the Population (in %) in Italy in 1991 to that in 1995?
Ensure brevity in your answer.  0.92. What is the ratio of the Population (in %) in Kyrgyz Republic in 1991 to that in 1995?
Your answer should be very brief. 0.94. What is the ratio of the Population (in %) in Italy in 1992 to that in 1993?
Your answer should be very brief. 0.98. What is the ratio of the Population (in %) in Kyrgyz Republic in 1992 to that in 1993?
Provide a short and direct response. 0.98. What is the ratio of the Population (in %) in Other small states in 1992 to that in 1994?
Your answer should be compact. 0.99. What is the ratio of the Population (in %) in Italy in 1992 to that in 1994?
Offer a terse response. 0.96. What is the ratio of the Population (in %) of Kyrgyz Republic in 1992 to that in 1994?
Keep it short and to the point. 0.96. What is the ratio of the Population (in %) in Other small states in 1992 to that in 1995?
Keep it short and to the point. 0.98. What is the ratio of the Population (in %) of Italy in 1992 to that in 1995?
Ensure brevity in your answer.  0.94. What is the ratio of the Population (in %) of Kyrgyz Republic in 1992 to that in 1995?
Your answer should be very brief. 0.96. What is the ratio of the Population (in %) in Congo (Republic) in 1993 to that in 1994?
Your answer should be compact. 1. What is the ratio of the Population (in %) of Italy in 1993 to that in 1994?
Offer a very short reply. 0.98. What is the ratio of the Population (in %) in Kyrgyz Republic in 1993 to that in 1994?
Your answer should be very brief. 0.99. What is the ratio of the Population (in %) in Other small states in 1993 to that in 1995?
Provide a succinct answer. 0.99. What is the ratio of the Population (in %) of Italy in 1993 to that in 1995?
Provide a short and direct response. 0.96. What is the ratio of the Population (in %) in Kyrgyz Republic in 1993 to that in 1995?
Ensure brevity in your answer.  0.98. What is the ratio of the Population (in %) in Other small states in 1994 to that in 1995?
Offer a terse response. 0.99. What is the ratio of the Population (in %) of Congo (Republic) in 1994 to that in 1995?
Make the answer very short. 1. What is the ratio of the Population (in %) in Italy in 1994 to that in 1995?
Offer a terse response. 0.98. What is the difference between the highest and the second highest Population (in %) of Other small states?
Make the answer very short. 0.02. What is the difference between the highest and the second highest Population (in %) in Congo (Republic)?
Offer a terse response. 0. What is the difference between the highest and the second highest Population (in %) in Italy?
Your answer should be compact. 0.32. What is the difference between the highest and the second highest Population (in %) in Kyrgyz Republic?
Provide a succinct answer. 0.01. What is the difference between the highest and the lowest Population (in %) of Other small states?
Give a very brief answer. 0.11. What is the difference between the highest and the lowest Population (in %) of Congo (Republic)?
Offer a terse response. 0.01. What is the difference between the highest and the lowest Population (in %) of Italy?
Provide a short and direct response. 2.05. What is the difference between the highest and the lowest Population (in %) in Kyrgyz Republic?
Your answer should be compact. 0.47. 